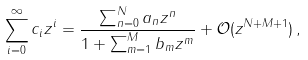<formula> <loc_0><loc_0><loc_500><loc_500>\sum _ { i = 0 } ^ { \infty } c _ { i } z ^ { i } = \frac { \sum _ { n = 0 } ^ { N } a _ { n } z ^ { n } } { 1 + \sum _ { m = 1 } ^ { M } b _ { m } z ^ { m } } + \mathcal { O } ( z ^ { N + M + 1 } ) \, ,</formula> 